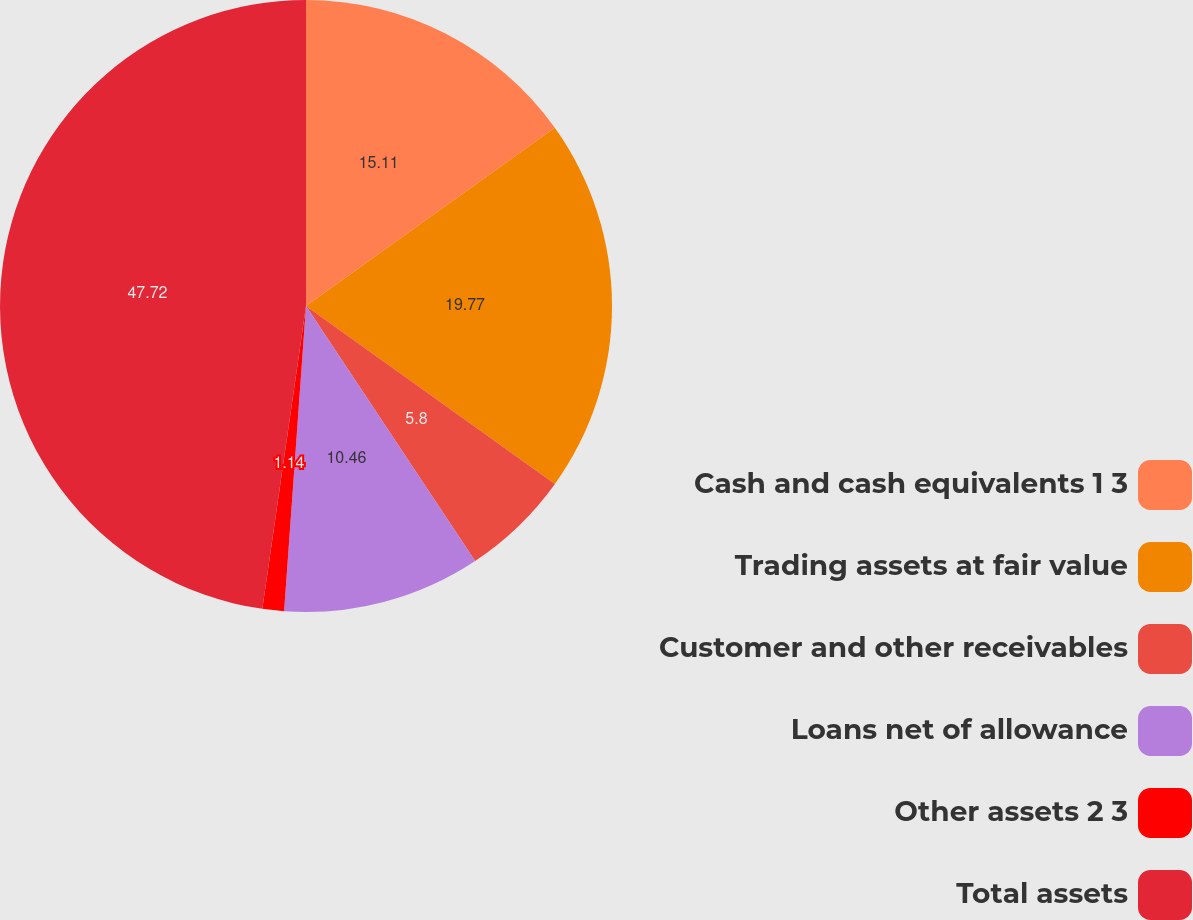Convert chart to OTSL. <chart><loc_0><loc_0><loc_500><loc_500><pie_chart><fcel>Cash and cash equivalents 1 3<fcel>Trading assets at fair value<fcel>Customer and other receivables<fcel>Loans net of allowance<fcel>Other assets 2 3<fcel>Total assets<nl><fcel>15.11%<fcel>19.77%<fcel>5.8%<fcel>10.46%<fcel>1.14%<fcel>47.72%<nl></chart> 